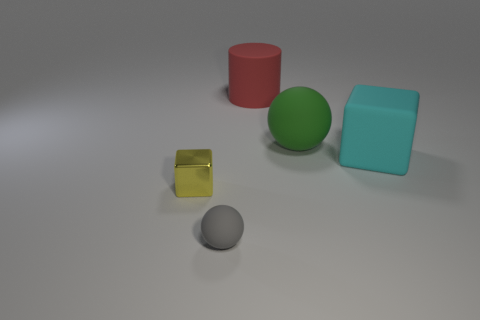What shape is the big cyan matte object? The large cyan object in the image has a cubic form, which is a three-dimensional shape with six equal square faces and edges of equal length. 